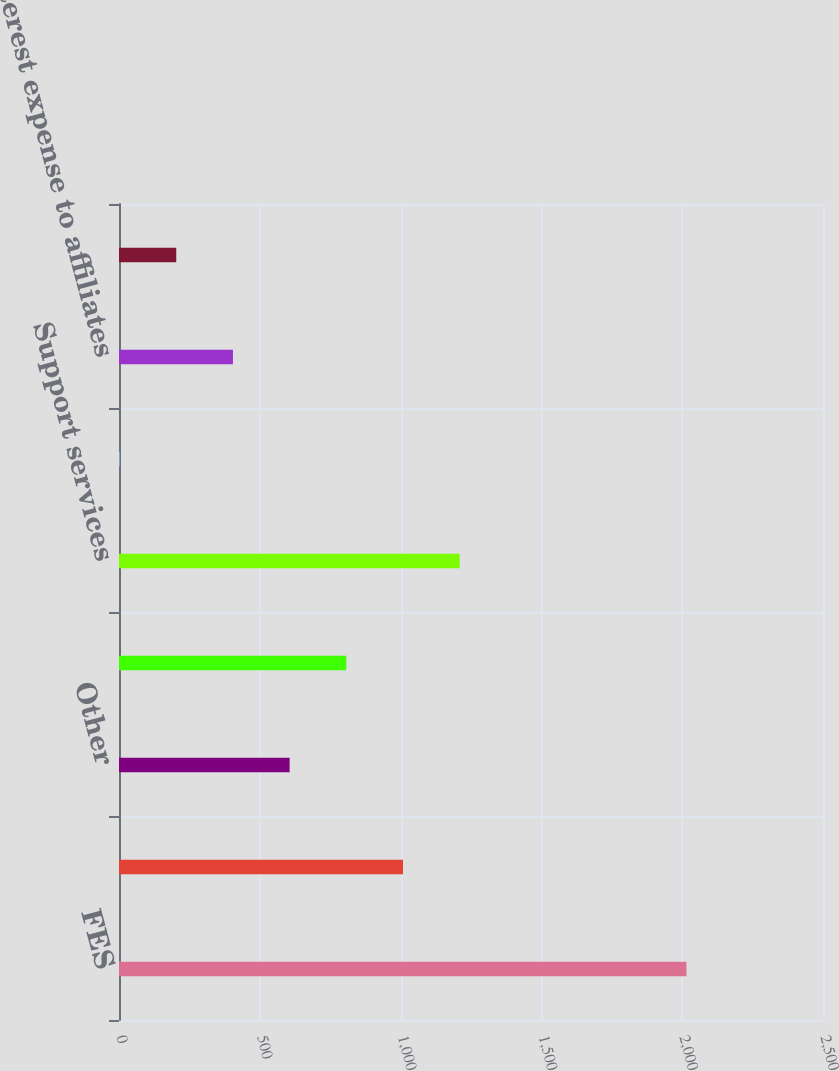Convert chart. <chart><loc_0><loc_0><loc_500><loc_500><bar_chart><fcel>FES<fcel>Electric sales to affiliates<fcel>Other<fcel>Purchased power from<fcel>Support services<fcel>Interest income from FE<fcel>Interest expense to affiliates<fcel>Interest expense to FE<nl><fcel>2015<fcel>1008.5<fcel>605.9<fcel>807.2<fcel>1209.8<fcel>2<fcel>404.6<fcel>203.3<nl></chart> 